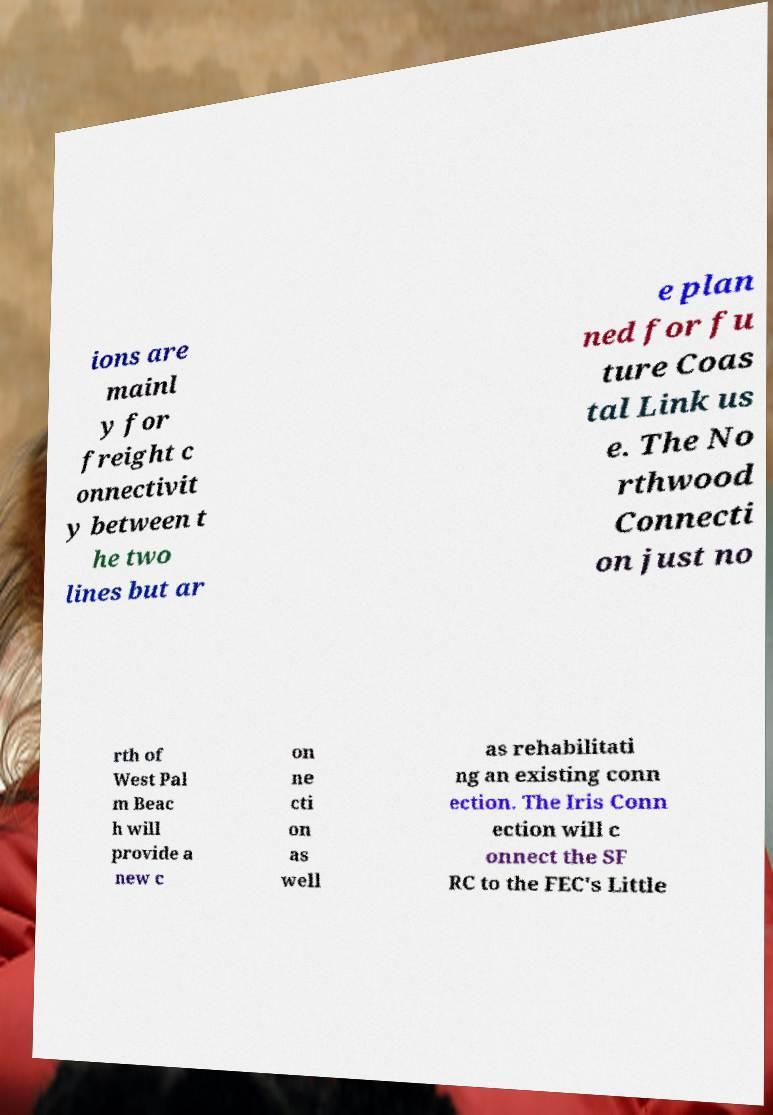What messages or text are displayed in this image? I need them in a readable, typed format. ions are mainl y for freight c onnectivit y between t he two lines but ar e plan ned for fu ture Coas tal Link us e. The No rthwood Connecti on just no rth of West Pal m Beac h will provide a new c on ne cti on as well as rehabilitati ng an existing conn ection. The Iris Conn ection will c onnect the SF RC to the FEC's Little 